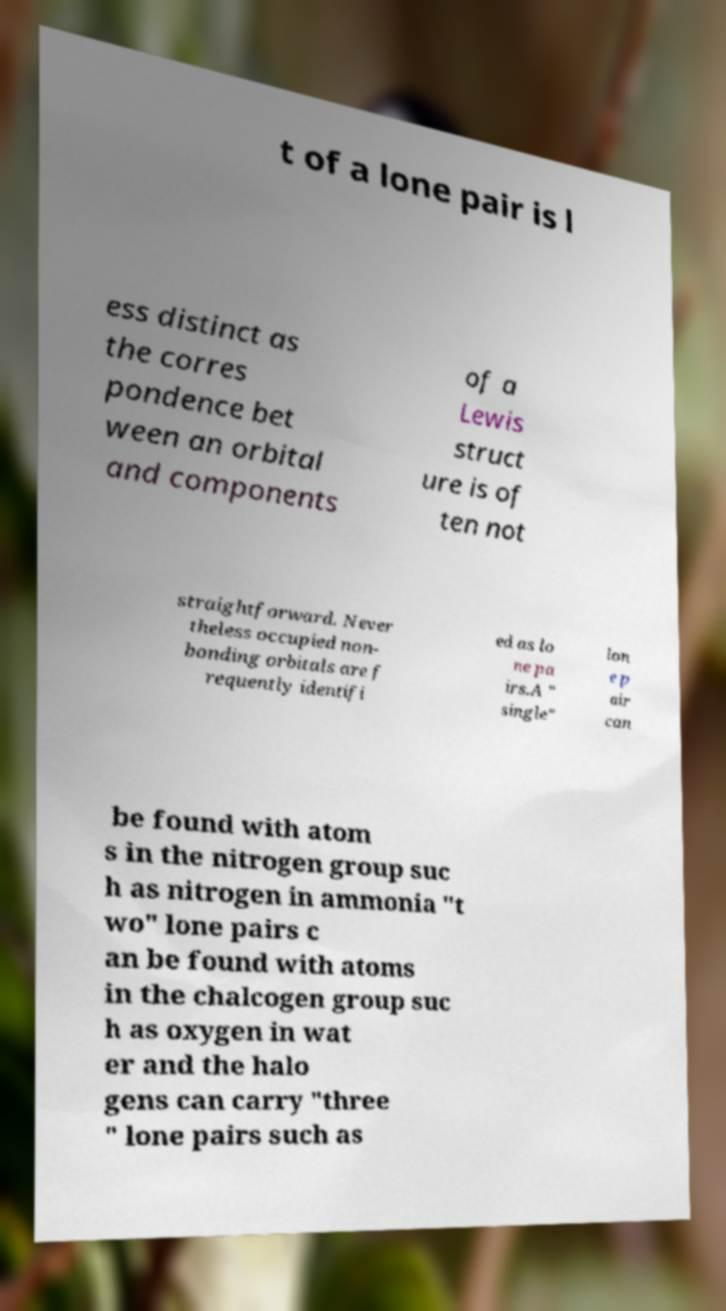Please read and relay the text visible in this image. What does it say? t of a lone pair is l ess distinct as the corres pondence bet ween an orbital and components of a Lewis struct ure is of ten not straightforward. Never theless occupied non- bonding orbitals are f requently identifi ed as lo ne pa irs.A " single" lon e p air can be found with atom s in the nitrogen group suc h as nitrogen in ammonia "t wo" lone pairs c an be found with atoms in the chalcogen group suc h as oxygen in wat er and the halo gens can carry "three " lone pairs such as 